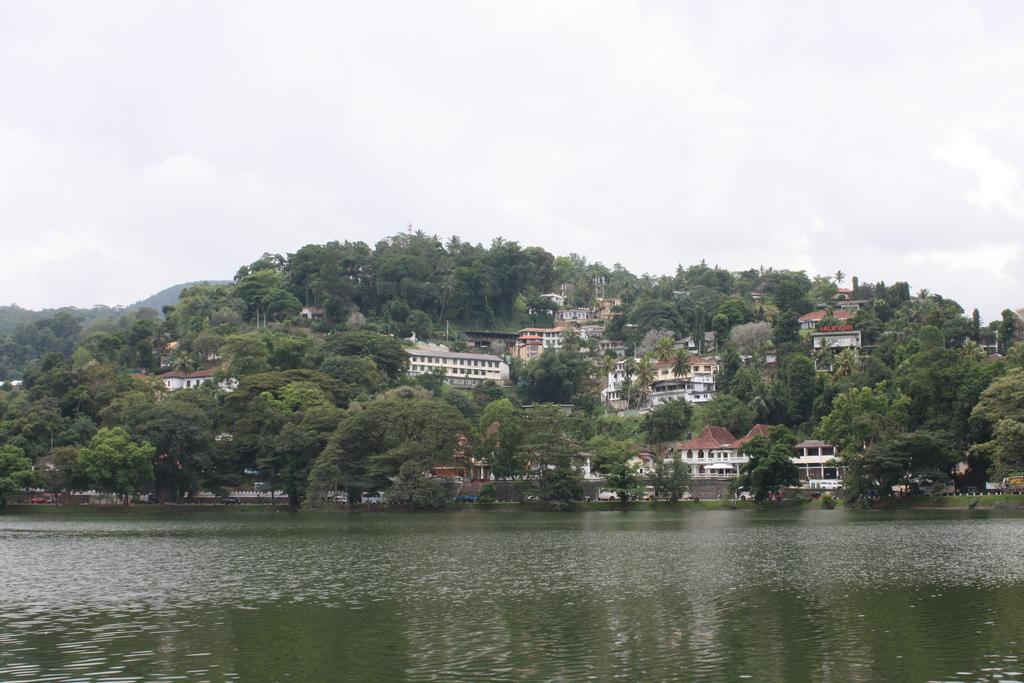What is located at the front of the image? There is a lake in the front of the image. What type of structures can be seen in the image? There are homes visible in the image. What type of vegetation is present in the image? Trees are present in the image. Where are the trees located in relation to the lake? The trees are on a hill. What is visible in the background of the image? The sky is visible in the image. What can be observed in the sky? Clouds are present in the sky. What type of reason is being discussed by the trees on the hill in the image? There are no trees discussing any reason in the image; they are simply trees on a hill. What payment method is being used by the clouds in the sky? There are no clouds using any payment method in the image; they are simply clouds in the sky. 